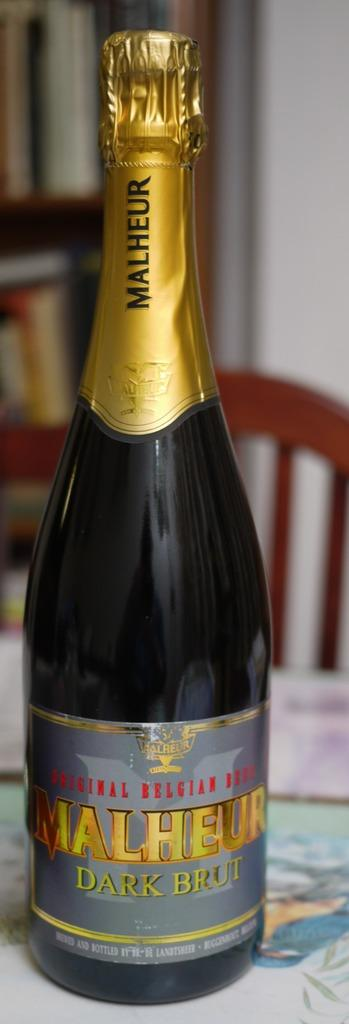<image>
Provide a brief description of the given image. A bottle of Malheur Dark Brut Belgian Beer 